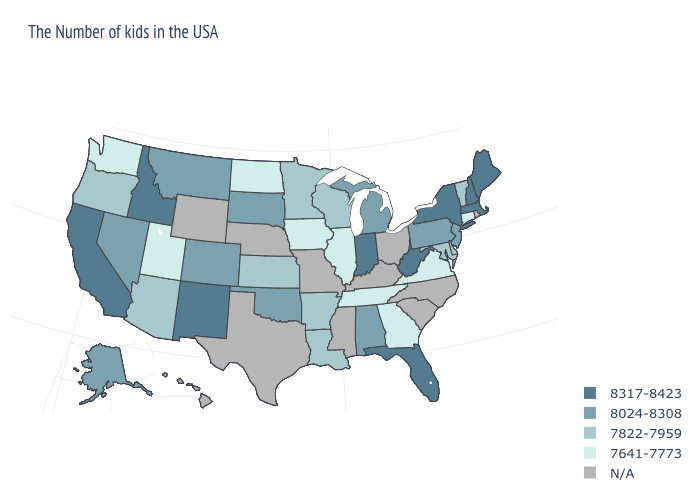Does West Virginia have the highest value in the South?
Keep it brief. Yes. Which states hav the highest value in the West?
Answer briefly. New Mexico, Idaho, California. What is the highest value in the Northeast ?
Be succinct. 8317-8423. Name the states that have a value in the range 7641-7773?
Write a very short answer. Connecticut, Virginia, Georgia, Tennessee, Illinois, Iowa, North Dakota, Utah, Washington. Does the map have missing data?
Keep it brief. Yes. Does Illinois have the highest value in the USA?
Quick response, please. No. Name the states that have a value in the range 7822-7959?
Give a very brief answer. Vermont, Delaware, Maryland, Wisconsin, Louisiana, Arkansas, Minnesota, Kansas, Arizona, Oregon. What is the value of Florida?
Give a very brief answer. 8317-8423. What is the highest value in the MidWest ?
Give a very brief answer. 8317-8423. Name the states that have a value in the range 7822-7959?
Give a very brief answer. Vermont, Delaware, Maryland, Wisconsin, Louisiana, Arkansas, Minnesota, Kansas, Arizona, Oregon. Does the map have missing data?
Short answer required. Yes. What is the value of Kansas?
Be succinct. 7822-7959. Which states have the lowest value in the Northeast?
Write a very short answer. Connecticut. Does Indiana have the highest value in the USA?
Write a very short answer. Yes. 